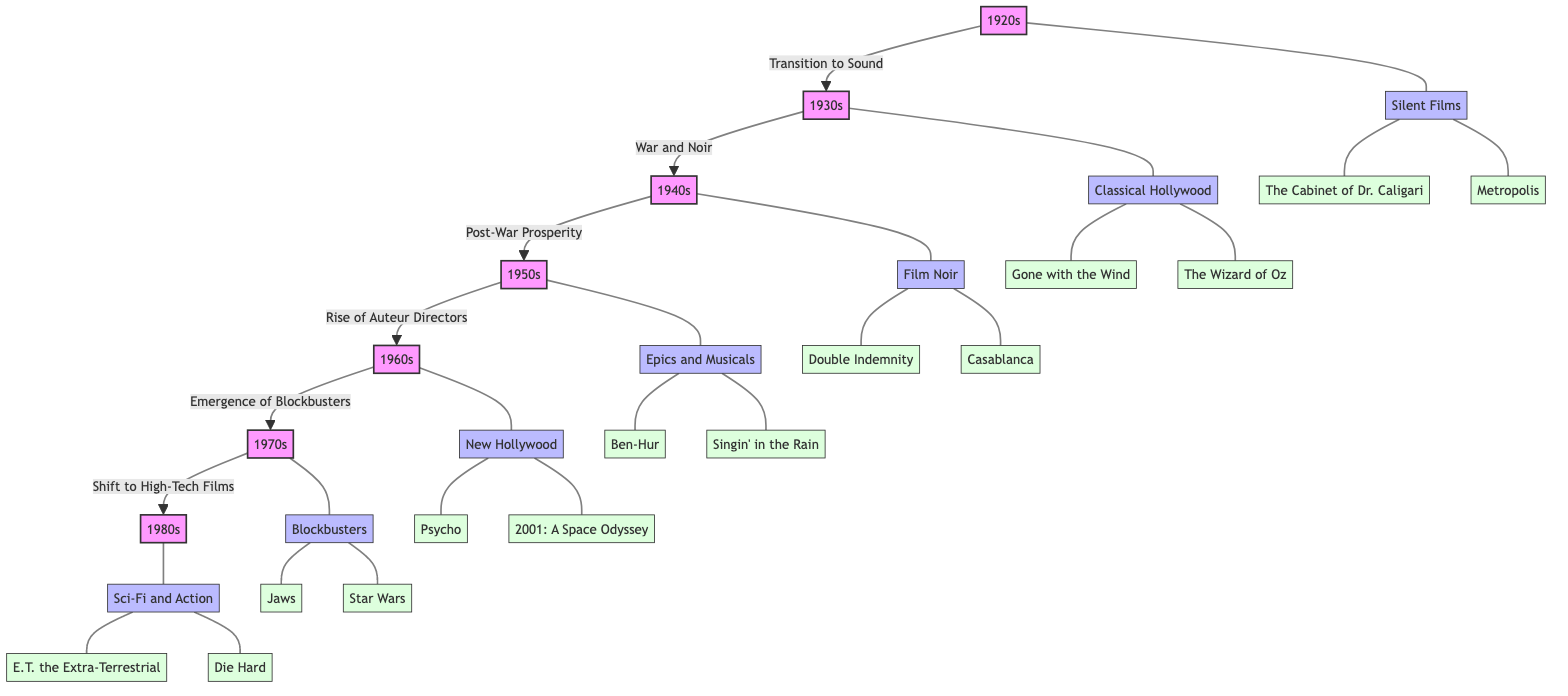What decade marked the transition to sound in cinema? The diagram indicates that the transition to sound occurred from the 1920s to the 1930s. Thus, the starting decade is the 1920s.
Answer: 1920s How many genres are represented in the diagram? By counting the genres listed in the flowchart, there are seven genres corresponding to each decade from the 1920s to the 1980s.
Answer: 7 Which film is associated with the genre of Classical Hollywood? In the diagram, the genre of Classical Hollywood from the 1930s is linked to "Gone with the Wind" and "The Wizard of Oz." Thus, one of the films listed is "Gone with the Wind."
Answer: Gone with the Wind What is the result of the shift from the 1960s to the 1970s? According to the flowchart, the shift from the 1960s to the 1970s indicates a transition from New Hollywood to the emergence of blockbusters, which signifies a change in filmmaking focus.
Answer: Emergence of Blockbusters Which two key films are shown under the genre of Sci-Fi and Action? The diagram details that the two key films associated with the Sci-Fi and Action genre from the 1980s are "E.T. the Extra-Terrestrial" and "Die Hard." Thus, these are the two films in that category.
Answer: E.T. the Extra-Terrestrial and Die Hard In what decade did the film "Double Indemnity" release? The diagram shows that "Double Indemnity" belongs to the genre of Film Noir, which is indicated under the 1940s decade. Therefore, the film was released in the 1940s.
Answer: 1940s Identify the decade known for Post-War Prosperity. The transition illustrated indicates that the 1940s leads into the 1950s, which is described as a decade of Post-War Prosperity. Therefore, the decade known is the 1950s.
Answer: 1950s What genre appeared first in the evolution of cinema according to the diagram? The first genre indicated by the flowchart corresponds to the 1920s, categorized as Silent Films. Thus, this genre started the evolution process depicted in the diagram.
Answer: Silent Films 